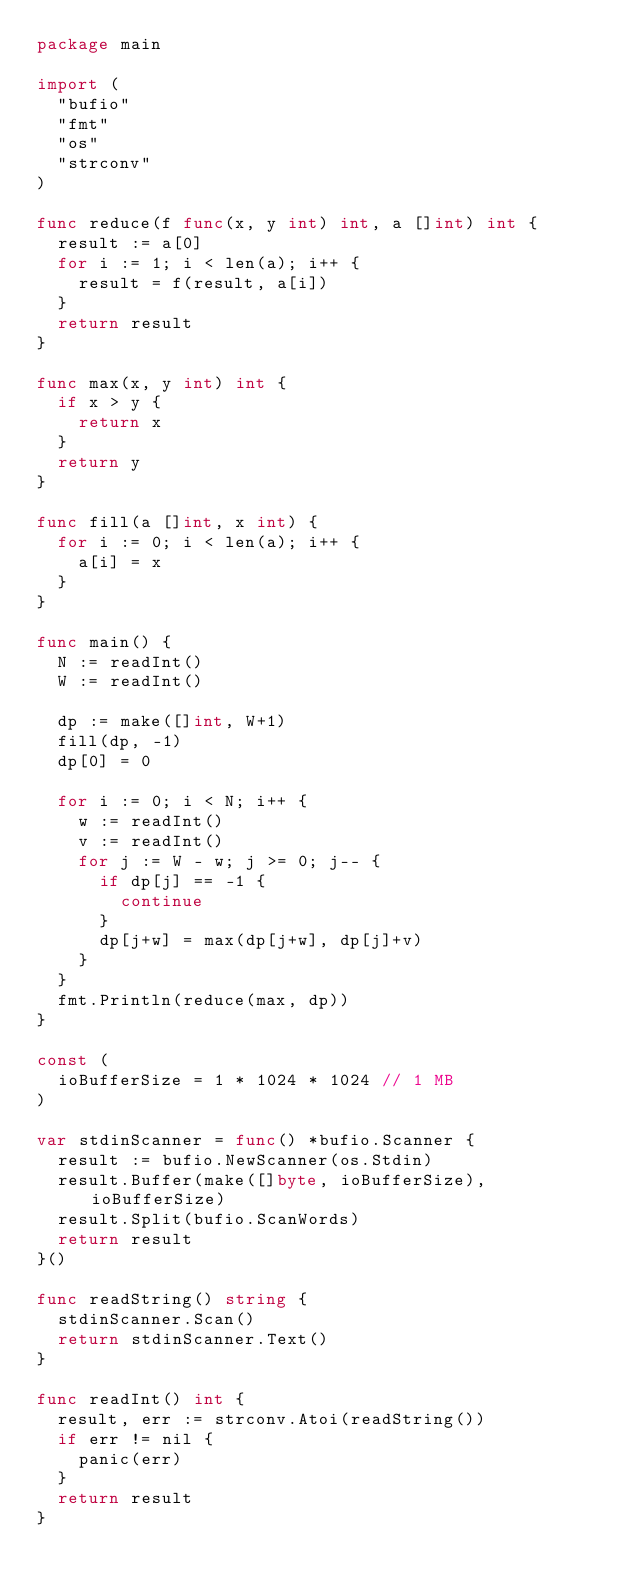<code> <loc_0><loc_0><loc_500><loc_500><_Go_>package main

import (
	"bufio"
	"fmt"
	"os"
	"strconv"
)

func reduce(f func(x, y int) int, a []int) int {
	result := a[0]
	for i := 1; i < len(a); i++ {
		result = f(result, a[i])
	}
	return result
}

func max(x, y int) int {
	if x > y {
		return x
	}
	return y
}

func fill(a []int, x int) {
	for i := 0; i < len(a); i++ {
		a[i] = x
	}
}

func main() {
	N := readInt()
	W := readInt()

	dp := make([]int, W+1)
	fill(dp, -1)
	dp[0] = 0

	for i := 0; i < N; i++ {
		w := readInt()
		v := readInt()
		for j := W - w; j >= 0; j-- {
			if dp[j] == -1 {
				continue
			}
			dp[j+w] = max(dp[j+w], dp[j]+v)
		}
	}
	fmt.Println(reduce(max, dp))
}

const (
	ioBufferSize = 1 * 1024 * 1024 // 1 MB
)

var stdinScanner = func() *bufio.Scanner {
	result := bufio.NewScanner(os.Stdin)
	result.Buffer(make([]byte, ioBufferSize), ioBufferSize)
	result.Split(bufio.ScanWords)
	return result
}()

func readString() string {
	stdinScanner.Scan()
	return stdinScanner.Text()
}

func readInt() int {
	result, err := strconv.Atoi(readString())
	if err != nil {
		panic(err)
	}
	return result
}
</code> 